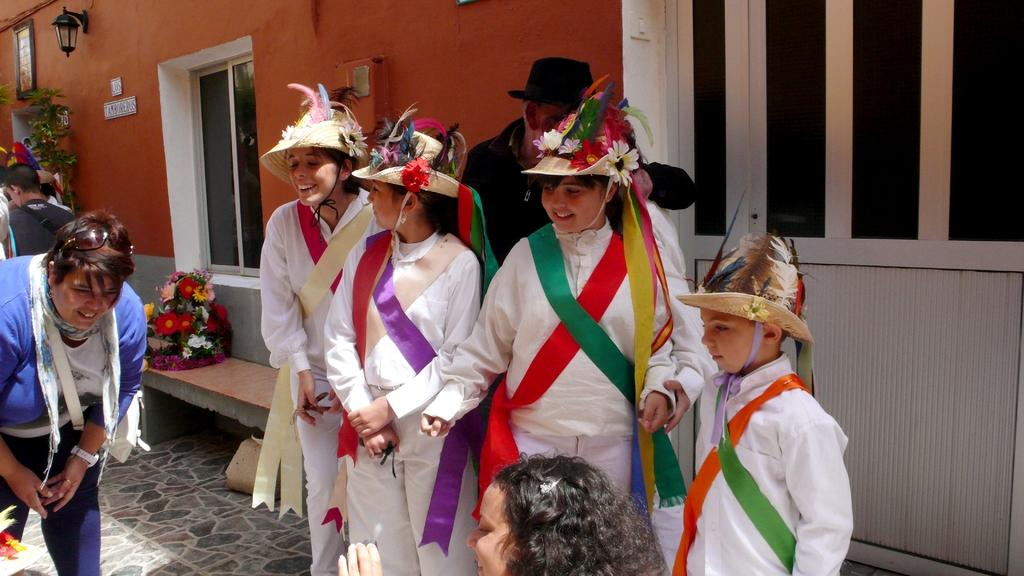What are the persons in the image wearing? The persons in the image are wearing costumes. Can you describe any architectural features in the image? Yes, there is a window in the image. What is hanging on the wall in the image? There is a photo frame on the wall in the image. What color is the wall visible in the background of the image? The wall in the background of the image is orange. How does the behavior of the persons in the image change when they see the angry surprise? There is no mention of anger or surprise in the image, and the persons' behavior cannot be determined based on the provided facts. 